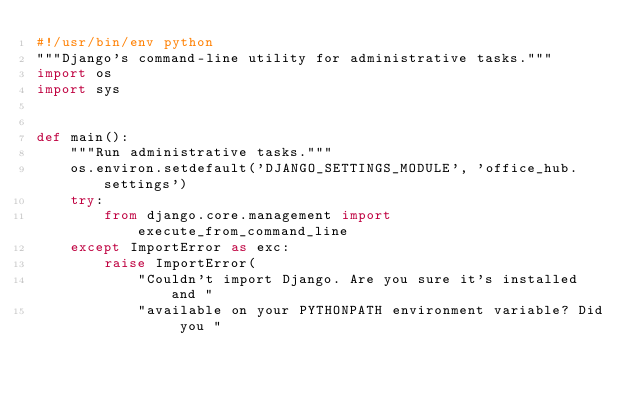<code> <loc_0><loc_0><loc_500><loc_500><_Python_>#!/usr/bin/env python
"""Django's command-line utility for administrative tasks."""
import os
import sys


def main():
    """Run administrative tasks."""
    os.environ.setdefault('DJANGO_SETTINGS_MODULE', 'office_hub.settings')
    try:
        from django.core.management import execute_from_command_line
    except ImportError as exc:
        raise ImportError(
            "Couldn't import Django. Are you sure it's installed and "
            "available on your PYTHONPATH environment variable? Did you "</code> 